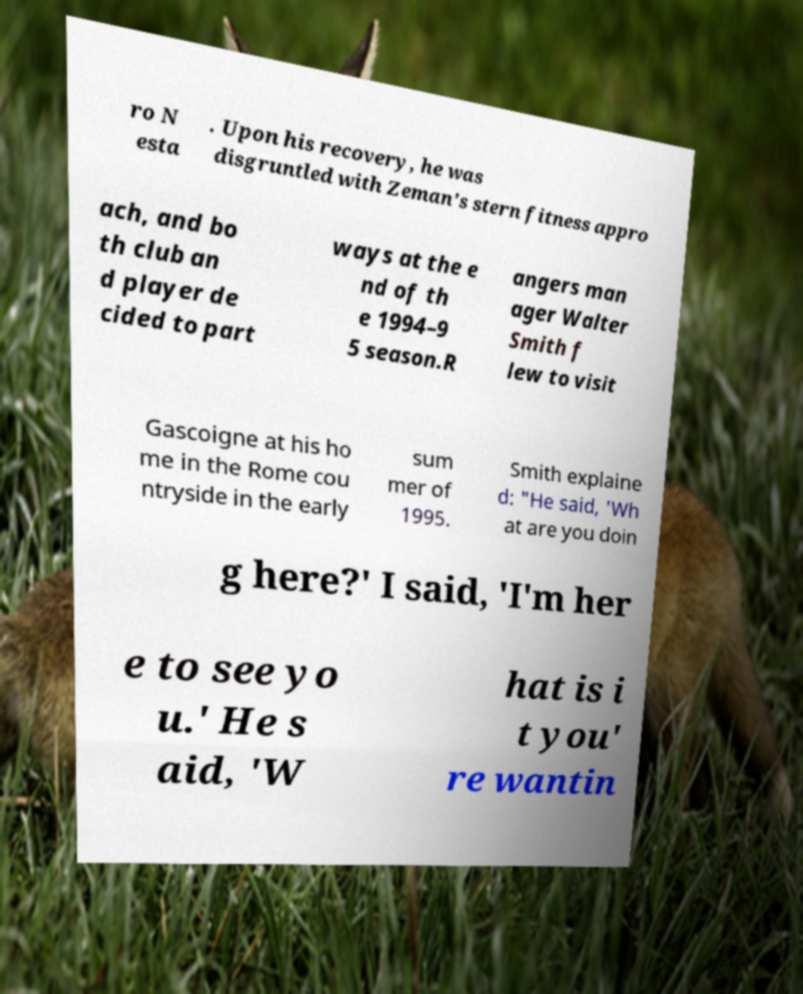Could you assist in decoding the text presented in this image and type it out clearly? ro N esta . Upon his recovery, he was disgruntled with Zeman's stern fitness appro ach, and bo th club an d player de cided to part ways at the e nd of th e 1994–9 5 season.R angers man ager Walter Smith f lew to visit Gascoigne at his ho me in the Rome cou ntryside in the early sum mer of 1995. Smith explaine d: "He said, 'Wh at are you doin g here?' I said, 'I'm her e to see yo u.' He s aid, 'W hat is i t you' re wantin 